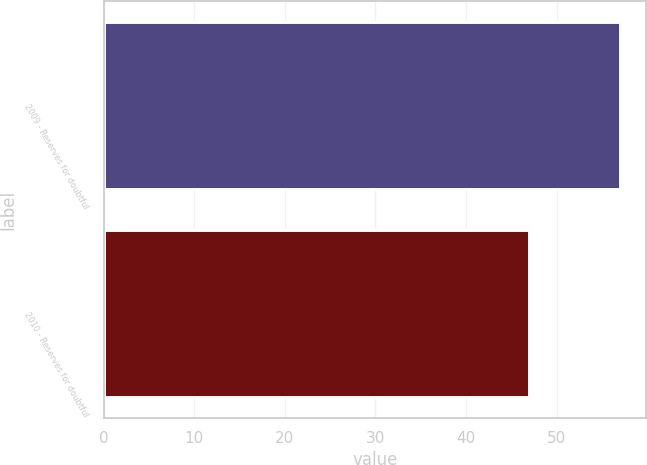Convert chart to OTSL. <chart><loc_0><loc_0><loc_500><loc_500><bar_chart><fcel>2009 - Reserves for doubtful<fcel>2010 - Reserves for doubtful<nl><fcel>57<fcel>47<nl></chart> 